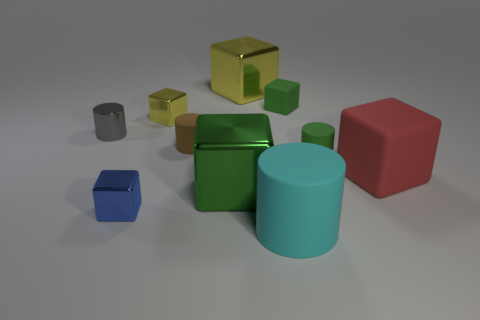What number of other things are there of the same color as the large matte cylinder?
Offer a terse response. 0. Is the number of tiny blue shiny things that are behind the big cyan cylinder greater than the number of brown matte cylinders on the left side of the tiny brown rubber cylinder?
Your response must be concise. Yes. What number of blocks are yellow metal objects or small brown rubber things?
Offer a terse response. 2. How many objects are either small things that are in front of the tiny green cylinder or tiny red cylinders?
Offer a very short reply. 1. What is the shape of the large rubber thing left of the rubber cylinder that is right of the cylinder in front of the green metallic block?
Your answer should be very brief. Cylinder. What number of other things have the same shape as the big red thing?
Your answer should be compact. 5. There is a big cube that is the same color as the tiny rubber cube; what is it made of?
Give a very brief answer. Metal. Are the small blue cube and the tiny yellow cube made of the same material?
Your answer should be compact. Yes. What number of objects are on the left side of the yellow shiny object that is behind the small metallic cube behind the blue metal block?
Give a very brief answer. 5. Is there a big cube made of the same material as the brown object?
Your response must be concise. Yes. 